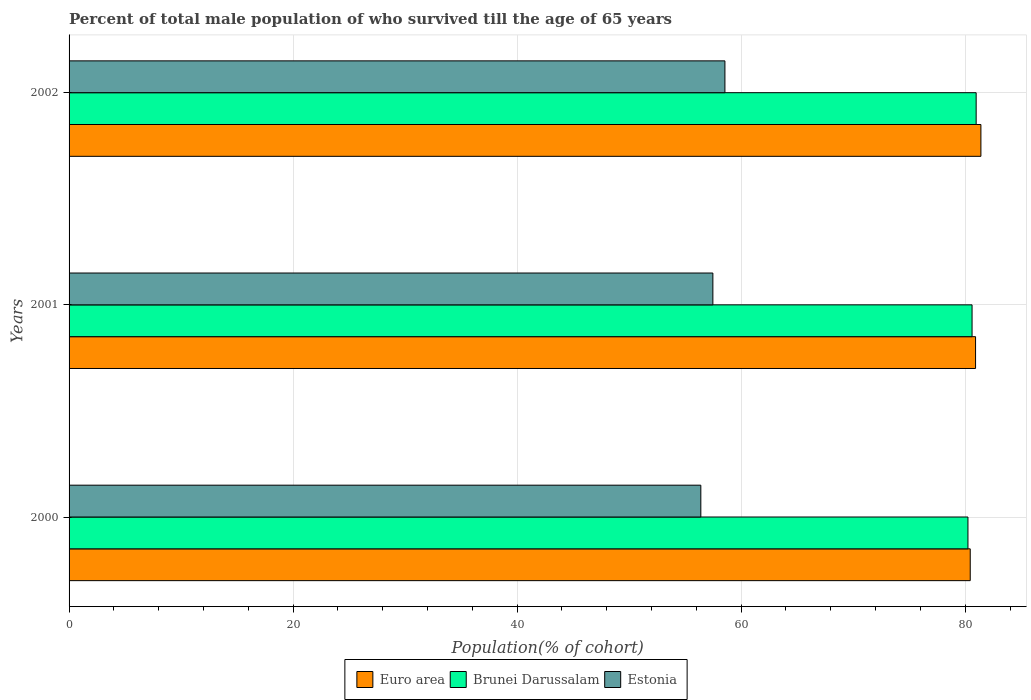How many groups of bars are there?
Make the answer very short. 3. Are the number of bars per tick equal to the number of legend labels?
Provide a short and direct response. Yes. Are the number of bars on each tick of the Y-axis equal?
Provide a short and direct response. Yes. How many bars are there on the 2nd tick from the top?
Keep it short and to the point. 3. How many bars are there on the 1st tick from the bottom?
Your answer should be very brief. 3. In how many cases, is the number of bars for a given year not equal to the number of legend labels?
Keep it short and to the point. 0. What is the percentage of total male population who survived till the age of 65 years in Estonia in 2002?
Provide a short and direct response. 58.55. Across all years, what is the maximum percentage of total male population who survived till the age of 65 years in Euro area?
Offer a very short reply. 81.4. Across all years, what is the minimum percentage of total male population who survived till the age of 65 years in Brunei Darussalam?
Provide a succinct answer. 80.25. In which year was the percentage of total male population who survived till the age of 65 years in Estonia maximum?
Offer a very short reply. 2002. In which year was the percentage of total male population who survived till the age of 65 years in Estonia minimum?
Provide a short and direct response. 2000. What is the total percentage of total male population who survived till the age of 65 years in Euro area in the graph?
Keep it short and to the point. 242.78. What is the difference between the percentage of total male population who survived till the age of 65 years in Euro area in 2001 and that in 2002?
Give a very brief answer. -0.48. What is the difference between the percentage of total male population who survived till the age of 65 years in Euro area in 2001 and the percentage of total male population who survived till the age of 65 years in Estonia in 2002?
Ensure brevity in your answer.  22.38. What is the average percentage of total male population who survived till the age of 65 years in Brunei Darussalam per year?
Make the answer very short. 80.61. In the year 2002, what is the difference between the percentage of total male population who survived till the age of 65 years in Brunei Darussalam and percentage of total male population who survived till the age of 65 years in Euro area?
Your response must be concise. -0.42. What is the ratio of the percentage of total male population who survived till the age of 65 years in Estonia in 2000 to that in 2001?
Ensure brevity in your answer.  0.98. Is the percentage of total male population who survived till the age of 65 years in Estonia in 2000 less than that in 2002?
Your response must be concise. Yes. What is the difference between the highest and the second highest percentage of total male population who survived till the age of 65 years in Estonia?
Keep it short and to the point. 1.08. What is the difference between the highest and the lowest percentage of total male population who survived till the age of 65 years in Estonia?
Make the answer very short. 2.15. Is the sum of the percentage of total male population who survived till the age of 65 years in Estonia in 2001 and 2002 greater than the maximum percentage of total male population who survived till the age of 65 years in Euro area across all years?
Make the answer very short. Yes. What does the 1st bar from the top in 2001 represents?
Ensure brevity in your answer.  Estonia. What does the 2nd bar from the bottom in 2001 represents?
Your answer should be very brief. Brunei Darussalam. How many years are there in the graph?
Offer a terse response. 3. Does the graph contain grids?
Give a very brief answer. Yes. What is the title of the graph?
Make the answer very short. Percent of total male population of who survived till the age of 65 years. What is the label or title of the X-axis?
Your answer should be very brief. Population(% of cohort). What is the Population(% of cohort) in Euro area in 2000?
Ensure brevity in your answer.  80.45. What is the Population(% of cohort) of Brunei Darussalam in 2000?
Offer a terse response. 80.25. What is the Population(% of cohort) of Estonia in 2000?
Make the answer very short. 56.4. What is the Population(% of cohort) of Euro area in 2001?
Offer a terse response. 80.93. What is the Population(% of cohort) in Brunei Darussalam in 2001?
Offer a very short reply. 80.61. What is the Population(% of cohort) in Estonia in 2001?
Provide a short and direct response. 57.47. What is the Population(% of cohort) of Euro area in 2002?
Provide a short and direct response. 81.4. What is the Population(% of cohort) in Brunei Darussalam in 2002?
Your answer should be compact. 80.98. What is the Population(% of cohort) of Estonia in 2002?
Give a very brief answer. 58.55. Across all years, what is the maximum Population(% of cohort) of Euro area?
Your answer should be very brief. 81.4. Across all years, what is the maximum Population(% of cohort) of Brunei Darussalam?
Provide a succinct answer. 80.98. Across all years, what is the maximum Population(% of cohort) in Estonia?
Give a very brief answer. 58.55. Across all years, what is the minimum Population(% of cohort) in Euro area?
Give a very brief answer. 80.45. Across all years, what is the minimum Population(% of cohort) in Brunei Darussalam?
Provide a short and direct response. 80.25. Across all years, what is the minimum Population(% of cohort) of Estonia?
Offer a very short reply. 56.4. What is the total Population(% of cohort) in Euro area in the graph?
Your answer should be compact. 242.78. What is the total Population(% of cohort) in Brunei Darussalam in the graph?
Ensure brevity in your answer.  241.84. What is the total Population(% of cohort) of Estonia in the graph?
Provide a short and direct response. 172.42. What is the difference between the Population(% of cohort) in Euro area in 2000 and that in 2001?
Offer a very short reply. -0.48. What is the difference between the Population(% of cohort) of Brunei Darussalam in 2000 and that in 2001?
Keep it short and to the point. -0.37. What is the difference between the Population(% of cohort) of Estonia in 2000 and that in 2001?
Offer a terse response. -1.08. What is the difference between the Population(% of cohort) of Euro area in 2000 and that in 2002?
Offer a very short reply. -0.95. What is the difference between the Population(% of cohort) in Brunei Darussalam in 2000 and that in 2002?
Your answer should be very brief. -0.73. What is the difference between the Population(% of cohort) of Estonia in 2000 and that in 2002?
Give a very brief answer. -2.15. What is the difference between the Population(% of cohort) in Euro area in 2001 and that in 2002?
Keep it short and to the point. -0.48. What is the difference between the Population(% of cohort) of Brunei Darussalam in 2001 and that in 2002?
Make the answer very short. -0.37. What is the difference between the Population(% of cohort) in Estonia in 2001 and that in 2002?
Keep it short and to the point. -1.08. What is the difference between the Population(% of cohort) of Euro area in 2000 and the Population(% of cohort) of Brunei Darussalam in 2001?
Offer a very short reply. -0.16. What is the difference between the Population(% of cohort) of Euro area in 2000 and the Population(% of cohort) of Estonia in 2001?
Provide a succinct answer. 22.97. What is the difference between the Population(% of cohort) in Brunei Darussalam in 2000 and the Population(% of cohort) in Estonia in 2001?
Provide a short and direct response. 22.77. What is the difference between the Population(% of cohort) in Euro area in 2000 and the Population(% of cohort) in Brunei Darussalam in 2002?
Provide a succinct answer. -0.53. What is the difference between the Population(% of cohort) of Euro area in 2000 and the Population(% of cohort) of Estonia in 2002?
Your answer should be compact. 21.9. What is the difference between the Population(% of cohort) of Brunei Darussalam in 2000 and the Population(% of cohort) of Estonia in 2002?
Your response must be concise. 21.7. What is the difference between the Population(% of cohort) in Euro area in 2001 and the Population(% of cohort) in Brunei Darussalam in 2002?
Your answer should be very brief. -0.05. What is the difference between the Population(% of cohort) of Euro area in 2001 and the Population(% of cohort) of Estonia in 2002?
Give a very brief answer. 22.38. What is the difference between the Population(% of cohort) in Brunei Darussalam in 2001 and the Population(% of cohort) in Estonia in 2002?
Your response must be concise. 22.06. What is the average Population(% of cohort) in Euro area per year?
Your answer should be very brief. 80.93. What is the average Population(% of cohort) of Brunei Darussalam per year?
Provide a succinct answer. 80.61. What is the average Population(% of cohort) of Estonia per year?
Give a very brief answer. 57.47. In the year 2000, what is the difference between the Population(% of cohort) in Euro area and Population(% of cohort) in Brunei Darussalam?
Give a very brief answer. 0.2. In the year 2000, what is the difference between the Population(% of cohort) of Euro area and Population(% of cohort) of Estonia?
Your response must be concise. 24.05. In the year 2000, what is the difference between the Population(% of cohort) of Brunei Darussalam and Population(% of cohort) of Estonia?
Provide a succinct answer. 23.85. In the year 2001, what is the difference between the Population(% of cohort) of Euro area and Population(% of cohort) of Brunei Darussalam?
Make the answer very short. 0.31. In the year 2001, what is the difference between the Population(% of cohort) of Euro area and Population(% of cohort) of Estonia?
Your answer should be very brief. 23.45. In the year 2001, what is the difference between the Population(% of cohort) of Brunei Darussalam and Population(% of cohort) of Estonia?
Offer a terse response. 23.14. In the year 2002, what is the difference between the Population(% of cohort) in Euro area and Population(% of cohort) in Brunei Darussalam?
Your response must be concise. 0.42. In the year 2002, what is the difference between the Population(% of cohort) in Euro area and Population(% of cohort) in Estonia?
Your response must be concise. 22.85. In the year 2002, what is the difference between the Population(% of cohort) of Brunei Darussalam and Population(% of cohort) of Estonia?
Make the answer very short. 22.43. What is the ratio of the Population(% of cohort) of Euro area in 2000 to that in 2001?
Offer a very short reply. 0.99. What is the ratio of the Population(% of cohort) in Brunei Darussalam in 2000 to that in 2001?
Your answer should be compact. 1. What is the ratio of the Population(% of cohort) of Estonia in 2000 to that in 2001?
Your response must be concise. 0.98. What is the ratio of the Population(% of cohort) of Euro area in 2000 to that in 2002?
Provide a succinct answer. 0.99. What is the ratio of the Population(% of cohort) in Estonia in 2000 to that in 2002?
Your answer should be very brief. 0.96. What is the ratio of the Population(% of cohort) of Brunei Darussalam in 2001 to that in 2002?
Provide a short and direct response. 1. What is the ratio of the Population(% of cohort) of Estonia in 2001 to that in 2002?
Give a very brief answer. 0.98. What is the difference between the highest and the second highest Population(% of cohort) in Euro area?
Your response must be concise. 0.48. What is the difference between the highest and the second highest Population(% of cohort) of Brunei Darussalam?
Offer a very short reply. 0.37. What is the difference between the highest and the second highest Population(% of cohort) in Estonia?
Offer a terse response. 1.08. What is the difference between the highest and the lowest Population(% of cohort) of Euro area?
Keep it short and to the point. 0.95. What is the difference between the highest and the lowest Population(% of cohort) of Brunei Darussalam?
Give a very brief answer. 0.73. What is the difference between the highest and the lowest Population(% of cohort) of Estonia?
Your answer should be compact. 2.15. 